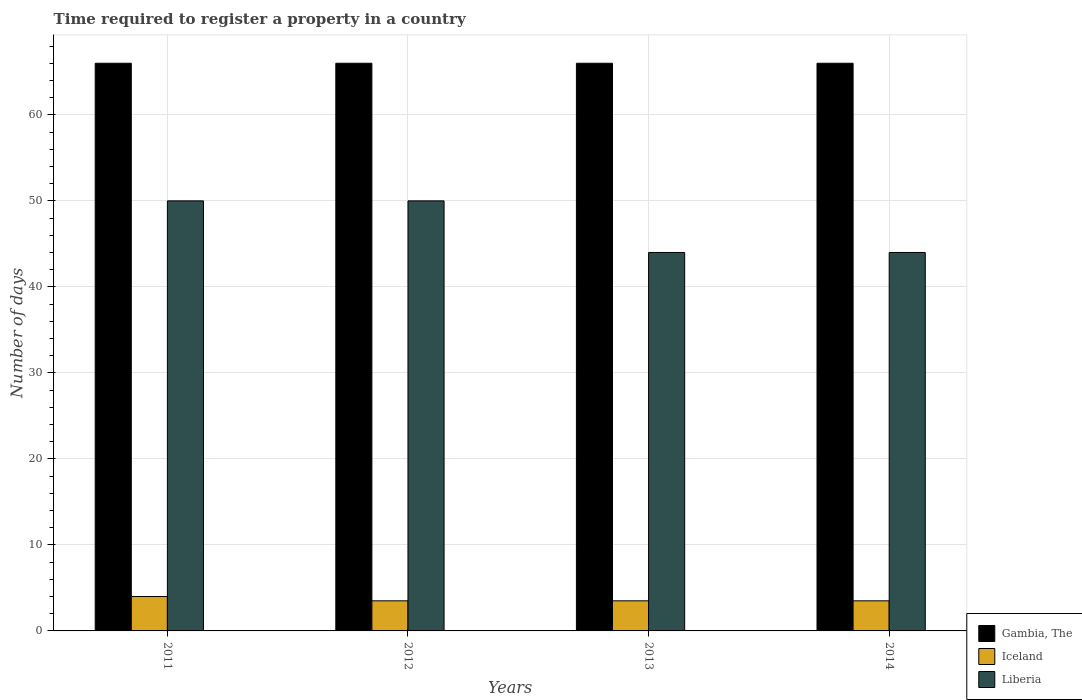How many different coloured bars are there?
Your answer should be compact. 3. How many groups of bars are there?
Provide a succinct answer. 4. How many bars are there on the 2nd tick from the right?
Make the answer very short. 3. What is the label of the 1st group of bars from the left?
Make the answer very short. 2011. In how many cases, is the number of bars for a given year not equal to the number of legend labels?
Offer a terse response. 0. What is the number of days required to register a property in Gambia, The in 2014?
Give a very brief answer. 66. Across all years, what is the maximum number of days required to register a property in Gambia, The?
Make the answer very short. 66. In which year was the number of days required to register a property in Gambia, The minimum?
Ensure brevity in your answer.  2011. What is the total number of days required to register a property in Liberia in the graph?
Provide a succinct answer. 188. What is the difference between the number of days required to register a property in Gambia, The in 2012 and that in 2014?
Give a very brief answer. 0. What is the difference between the number of days required to register a property in Gambia, The in 2012 and the number of days required to register a property in Liberia in 2013?
Offer a terse response. 22. What is the average number of days required to register a property in Iceland per year?
Offer a very short reply. 3.62. In how many years, is the number of days required to register a property in Iceland greater than 46 days?
Your answer should be very brief. 0. Is the number of days required to register a property in Liberia in 2011 less than that in 2013?
Give a very brief answer. No. What is the difference between the highest and the lowest number of days required to register a property in Iceland?
Keep it short and to the point. 0.5. In how many years, is the number of days required to register a property in Gambia, The greater than the average number of days required to register a property in Gambia, The taken over all years?
Your answer should be compact. 0. What does the 1st bar from the left in 2014 represents?
Your answer should be compact. Gambia, The. What does the 2nd bar from the right in 2012 represents?
Offer a terse response. Iceland. Is it the case that in every year, the sum of the number of days required to register a property in Iceland and number of days required to register a property in Gambia, The is greater than the number of days required to register a property in Liberia?
Your answer should be very brief. Yes. How many years are there in the graph?
Offer a terse response. 4. Does the graph contain any zero values?
Make the answer very short. No. Where does the legend appear in the graph?
Make the answer very short. Bottom right. What is the title of the graph?
Provide a short and direct response. Time required to register a property in a country. What is the label or title of the Y-axis?
Your response must be concise. Number of days. What is the Number of days in Iceland in 2011?
Make the answer very short. 4. What is the Number of days of Gambia, The in 2012?
Provide a short and direct response. 66. What is the Number of days of Iceland in 2012?
Give a very brief answer. 3.5. What is the Number of days of Liberia in 2012?
Provide a succinct answer. 50. What is the Number of days of Liberia in 2013?
Offer a very short reply. 44. What is the Number of days of Gambia, The in 2014?
Ensure brevity in your answer.  66. What is the Number of days in Liberia in 2014?
Give a very brief answer. 44. Across all years, what is the minimum Number of days in Iceland?
Offer a terse response. 3.5. Across all years, what is the minimum Number of days of Liberia?
Provide a short and direct response. 44. What is the total Number of days of Gambia, The in the graph?
Offer a very short reply. 264. What is the total Number of days in Iceland in the graph?
Offer a very short reply. 14.5. What is the total Number of days of Liberia in the graph?
Keep it short and to the point. 188. What is the difference between the Number of days in Gambia, The in 2011 and that in 2012?
Your answer should be very brief. 0. What is the difference between the Number of days of Iceland in 2011 and that in 2012?
Provide a short and direct response. 0.5. What is the difference between the Number of days in Liberia in 2011 and that in 2013?
Ensure brevity in your answer.  6. What is the difference between the Number of days of Liberia in 2011 and that in 2014?
Keep it short and to the point. 6. What is the difference between the Number of days of Gambia, The in 2012 and that in 2013?
Your answer should be compact. 0. What is the difference between the Number of days of Gambia, The in 2012 and that in 2014?
Provide a short and direct response. 0. What is the difference between the Number of days of Iceland in 2012 and that in 2014?
Your response must be concise. 0. What is the difference between the Number of days in Iceland in 2013 and that in 2014?
Offer a terse response. 0. What is the difference between the Number of days in Gambia, The in 2011 and the Number of days in Iceland in 2012?
Provide a succinct answer. 62.5. What is the difference between the Number of days of Gambia, The in 2011 and the Number of days of Liberia in 2012?
Offer a very short reply. 16. What is the difference between the Number of days of Iceland in 2011 and the Number of days of Liberia in 2012?
Your response must be concise. -46. What is the difference between the Number of days of Gambia, The in 2011 and the Number of days of Iceland in 2013?
Your answer should be very brief. 62.5. What is the difference between the Number of days of Iceland in 2011 and the Number of days of Liberia in 2013?
Provide a succinct answer. -40. What is the difference between the Number of days of Gambia, The in 2011 and the Number of days of Iceland in 2014?
Provide a short and direct response. 62.5. What is the difference between the Number of days in Gambia, The in 2011 and the Number of days in Liberia in 2014?
Offer a terse response. 22. What is the difference between the Number of days in Gambia, The in 2012 and the Number of days in Iceland in 2013?
Your response must be concise. 62.5. What is the difference between the Number of days in Iceland in 2012 and the Number of days in Liberia in 2013?
Make the answer very short. -40.5. What is the difference between the Number of days in Gambia, The in 2012 and the Number of days in Iceland in 2014?
Ensure brevity in your answer.  62.5. What is the difference between the Number of days in Gambia, The in 2012 and the Number of days in Liberia in 2014?
Your answer should be very brief. 22. What is the difference between the Number of days of Iceland in 2012 and the Number of days of Liberia in 2014?
Your answer should be compact. -40.5. What is the difference between the Number of days in Gambia, The in 2013 and the Number of days in Iceland in 2014?
Keep it short and to the point. 62.5. What is the difference between the Number of days of Gambia, The in 2013 and the Number of days of Liberia in 2014?
Provide a short and direct response. 22. What is the difference between the Number of days in Iceland in 2013 and the Number of days in Liberia in 2014?
Your answer should be very brief. -40.5. What is the average Number of days in Gambia, The per year?
Ensure brevity in your answer.  66. What is the average Number of days of Iceland per year?
Provide a short and direct response. 3.62. What is the average Number of days of Liberia per year?
Offer a terse response. 47. In the year 2011, what is the difference between the Number of days in Gambia, The and Number of days in Liberia?
Provide a succinct answer. 16. In the year 2011, what is the difference between the Number of days of Iceland and Number of days of Liberia?
Give a very brief answer. -46. In the year 2012, what is the difference between the Number of days in Gambia, The and Number of days in Iceland?
Give a very brief answer. 62.5. In the year 2012, what is the difference between the Number of days of Iceland and Number of days of Liberia?
Your answer should be very brief. -46.5. In the year 2013, what is the difference between the Number of days in Gambia, The and Number of days in Iceland?
Provide a succinct answer. 62.5. In the year 2013, what is the difference between the Number of days in Gambia, The and Number of days in Liberia?
Ensure brevity in your answer.  22. In the year 2013, what is the difference between the Number of days of Iceland and Number of days of Liberia?
Your answer should be very brief. -40.5. In the year 2014, what is the difference between the Number of days of Gambia, The and Number of days of Iceland?
Offer a very short reply. 62.5. In the year 2014, what is the difference between the Number of days in Iceland and Number of days in Liberia?
Keep it short and to the point. -40.5. What is the ratio of the Number of days in Gambia, The in 2011 to that in 2012?
Offer a very short reply. 1. What is the ratio of the Number of days in Liberia in 2011 to that in 2012?
Offer a very short reply. 1. What is the ratio of the Number of days in Iceland in 2011 to that in 2013?
Your answer should be compact. 1.14. What is the ratio of the Number of days in Liberia in 2011 to that in 2013?
Your answer should be very brief. 1.14. What is the ratio of the Number of days of Gambia, The in 2011 to that in 2014?
Keep it short and to the point. 1. What is the ratio of the Number of days in Iceland in 2011 to that in 2014?
Your response must be concise. 1.14. What is the ratio of the Number of days in Liberia in 2011 to that in 2014?
Your answer should be compact. 1.14. What is the ratio of the Number of days of Iceland in 2012 to that in 2013?
Your answer should be very brief. 1. What is the ratio of the Number of days in Liberia in 2012 to that in 2013?
Keep it short and to the point. 1.14. What is the ratio of the Number of days in Gambia, The in 2012 to that in 2014?
Offer a terse response. 1. What is the ratio of the Number of days in Liberia in 2012 to that in 2014?
Your response must be concise. 1.14. What is the ratio of the Number of days of Iceland in 2013 to that in 2014?
Ensure brevity in your answer.  1. What is the ratio of the Number of days in Liberia in 2013 to that in 2014?
Offer a terse response. 1. What is the difference between the highest and the second highest Number of days in Gambia, The?
Offer a terse response. 0. What is the difference between the highest and the second highest Number of days in Iceland?
Ensure brevity in your answer.  0.5. What is the difference between the highest and the second highest Number of days in Liberia?
Give a very brief answer. 0. What is the difference between the highest and the lowest Number of days in Gambia, The?
Your response must be concise. 0. What is the difference between the highest and the lowest Number of days in Iceland?
Your answer should be very brief. 0.5. What is the difference between the highest and the lowest Number of days in Liberia?
Give a very brief answer. 6. 